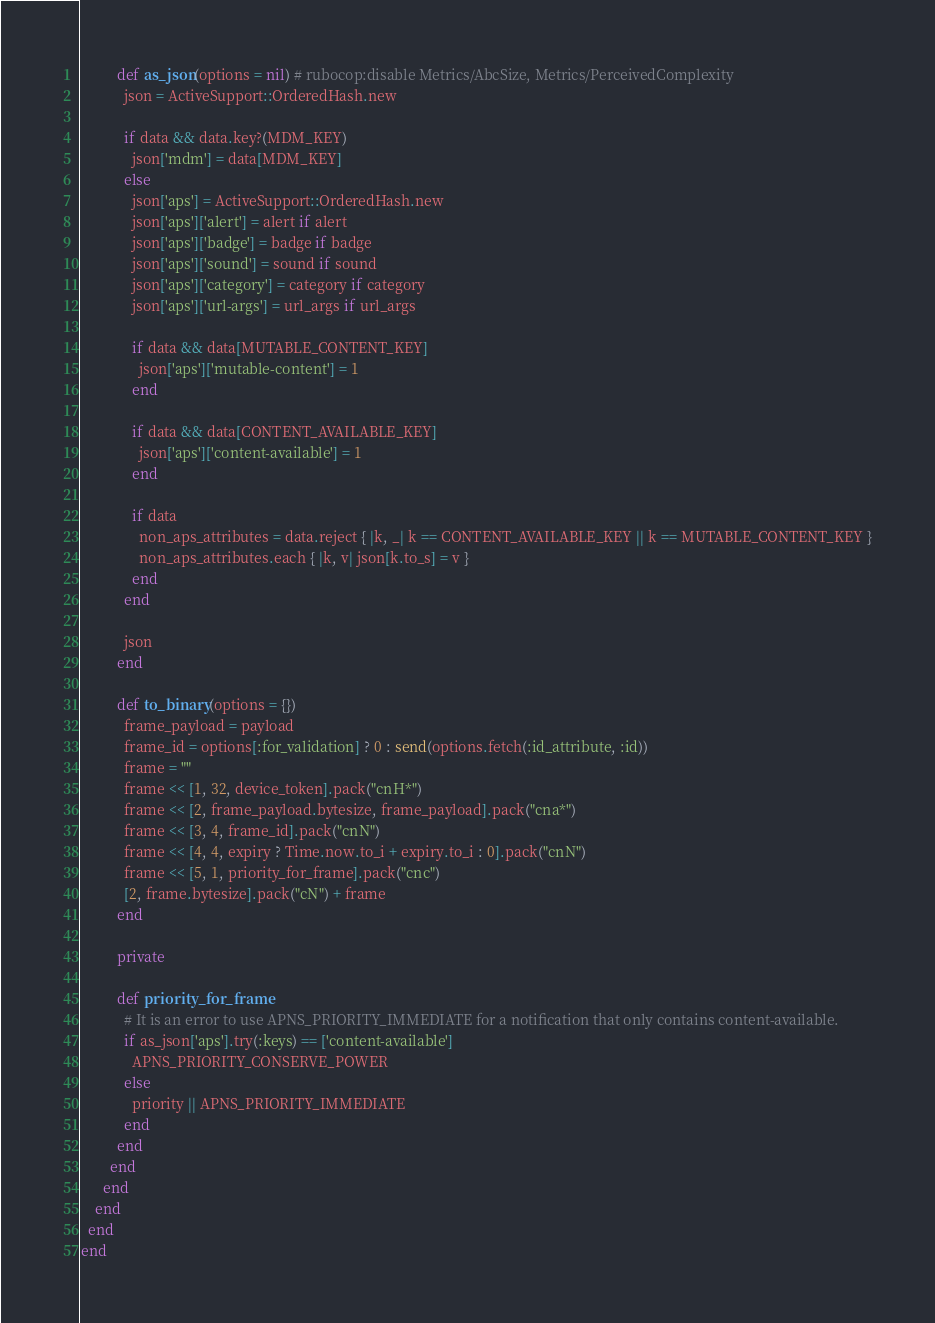<code> <loc_0><loc_0><loc_500><loc_500><_Ruby_>
          def as_json(options = nil) # rubocop:disable Metrics/AbcSize, Metrics/PerceivedComplexity
            json = ActiveSupport::OrderedHash.new

            if data && data.key?(MDM_KEY)
              json['mdm'] = data[MDM_KEY]
            else
              json['aps'] = ActiveSupport::OrderedHash.new
              json['aps']['alert'] = alert if alert
              json['aps']['badge'] = badge if badge
              json['aps']['sound'] = sound if sound
              json['aps']['category'] = category if category
              json['aps']['url-args'] = url_args if url_args

              if data && data[MUTABLE_CONTENT_KEY]
                json['aps']['mutable-content'] = 1
              end

              if data && data[CONTENT_AVAILABLE_KEY]
                json['aps']['content-available'] = 1
              end

              if data
                non_aps_attributes = data.reject { |k, _| k == CONTENT_AVAILABLE_KEY || k == MUTABLE_CONTENT_KEY }
                non_aps_attributes.each { |k, v| json[k.to_s] = v }
              end
            end

            json
          end

          def to_binary(options = {})
            frame_payload = payload
            frame_id = options[:for_validation] ? 0 : send(options.fetch(:id_attribute, :id))
            frame = ""
            frame << [1, 32, device_token].pack("cnH*")
            frame << [2, frame_payload.bytesize, frame_payload].pack("cna*")
            frame << [3, 4, frame_id].pack("cnN")
            frame << [4, 4, expiry ? Time.now.to_i + expiry.to_i : 0].pack("cnN")
            frame << [5, 1, priority_for_frame].pack("cnc")
            [2, frame.bytesize].pack("cN") + frame
          end

          private

          def priority_for_frame
            # It is an error to use APNS_PRIORITY_IMMEDIATE for a notification that only contains content-available.
            if as_json['aps'].try(:keys) == ['content-available']
              APNS_PRIORITY_CONSERVE_POWER
            else
              priority || APNS_PRIORITY_IMMEDIATE
            end
          end
        end
      end
    end
  end
end
</code> 